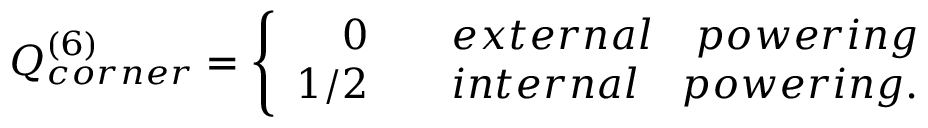Convert formula to latex. <formula><loc_0><loc_0><loc_500><loc_500>Q _ { c o r n e r } ^ { ( 6 ) } = \left \{ \begin{array} { r c l } { 0 } & { e x t e r n a l \quad p o w e r i n g } \\ { 1 / 2 } & { { i n t e r n a l \quad p o w e r i n g } . } \end{array}</formula> 